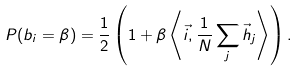<formula> <loc_0><loc_0><loc_500><loc_500>P ( b _ { i } = \beta ) = \frac { 1 } { 2 } \left ( 1 + \beta \left \langle \vec { i } , \frac { 1 } { N } \sum _ { j } \vec { h } _ { j } \right \rangle \right ) .</formula> 